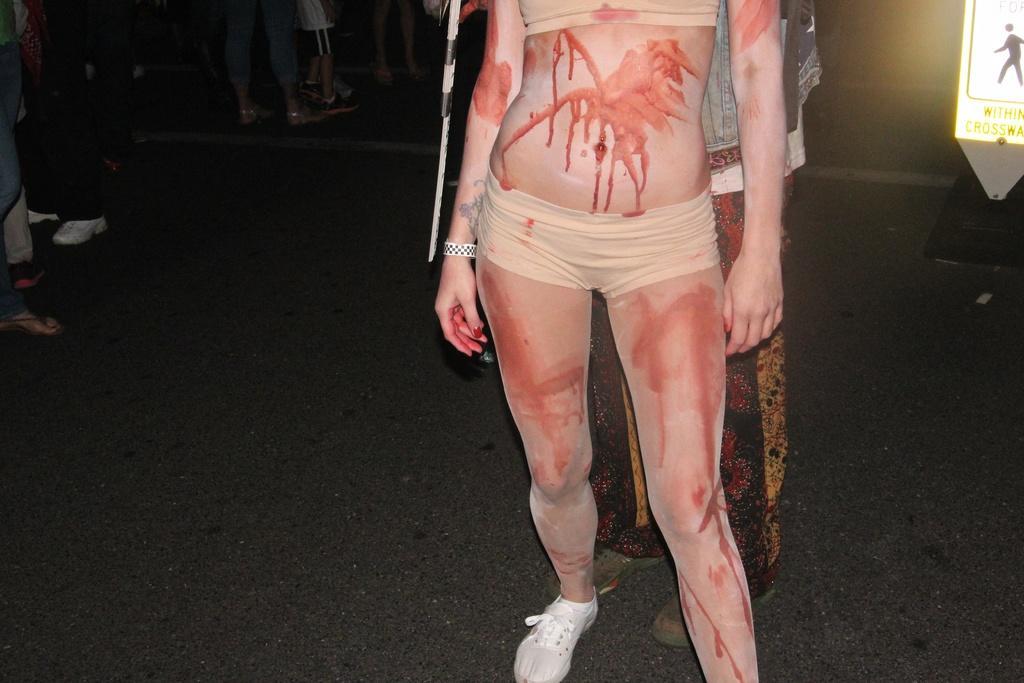Can you describe this image briefly? In this picture there is a girl in the center of the image, it seems to be there is color on her body and there are other people in the background area of the image and there is sign board in the top right side of the image. 